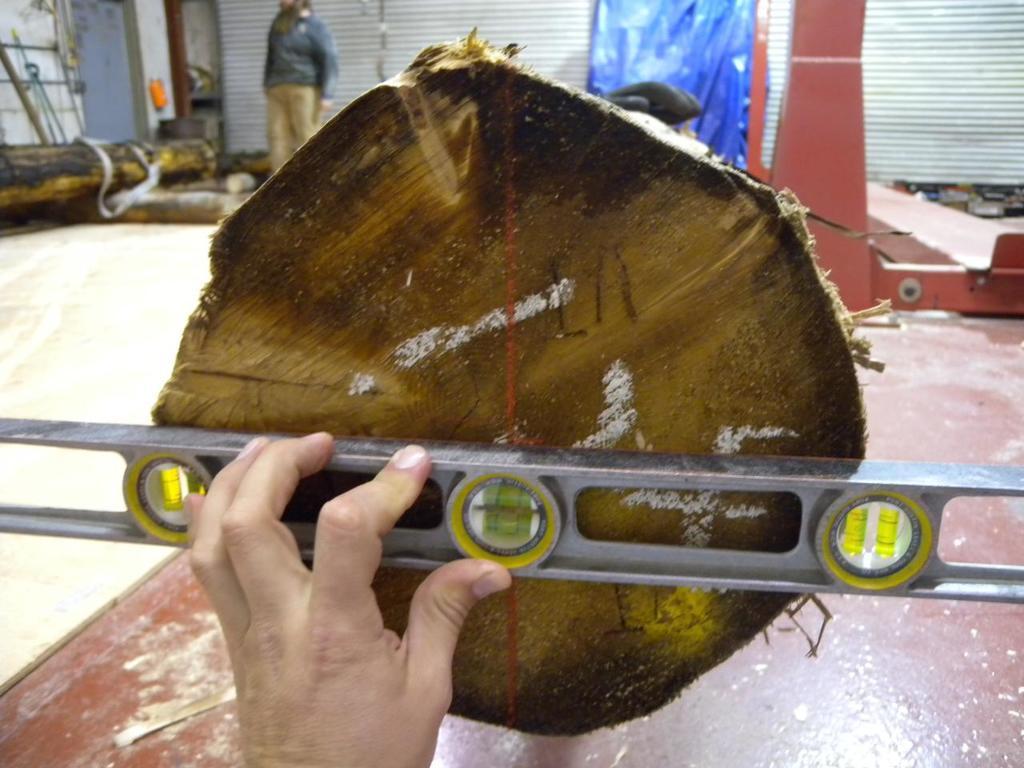In one or two sentences, can you explain what this image depicts? In the center of the image we can see a person measuring a wood placed on the table. In the background there are wooden blocks, person, curtain and wall. 